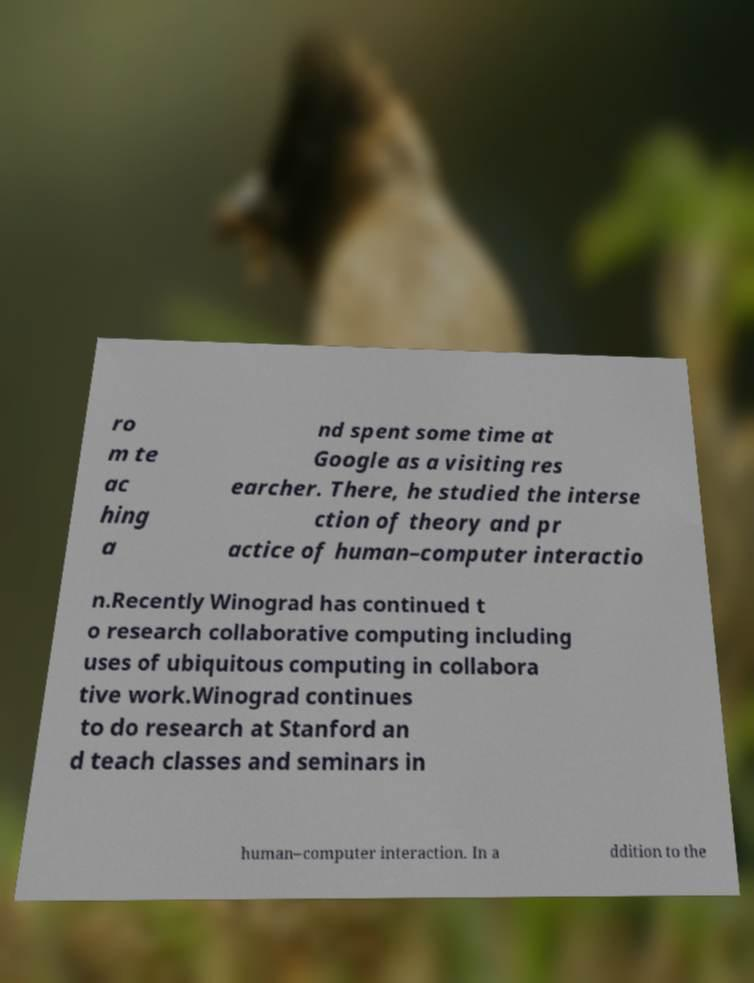Please identify and transcribe the text found in this image. ro m te ac hing a nd spent some time at Google as a visiting res earcher. There, he studied the interse ction of theory and pr actice of human–computer interactio n.Recently Winograd has continued t o research collaborative computing including uses of ubiquitous computing in collabora tive work.Winograd continues to do research at Stanford an d teach classes and seminars in human–computer interaction. In a ddition to the 